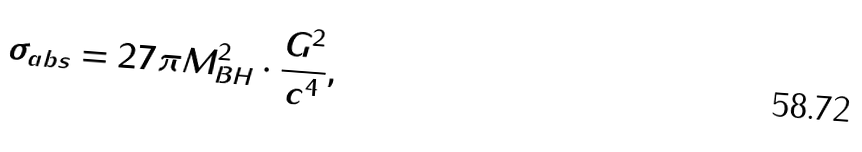<formula> <loc_0><loc_0><loc_500><loc_500>\sigma _ { a b s } = 2 7 \pi M _ { B H } ^ { 2 } \cdot \frac { G ^ { 2 } } { c ^ { 4 } } ,</formula> 